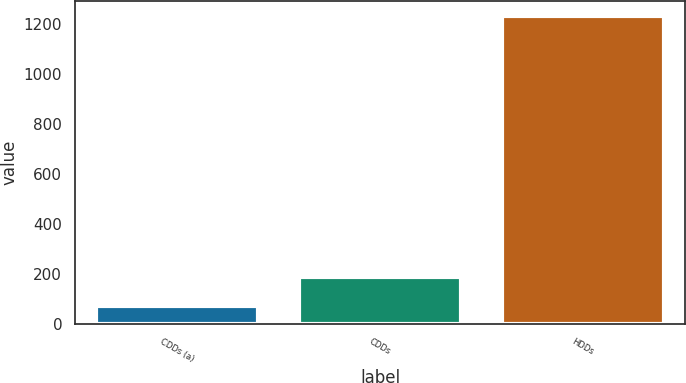<chart> <loc_0><loc_0><loc_500><loc_500><bar_chart><fcel>CDDs (a)<fcel>CDDs<fcel>HDDs<nl><fcel>71<fcel>187.2<fcel>1233<nl></chart> 